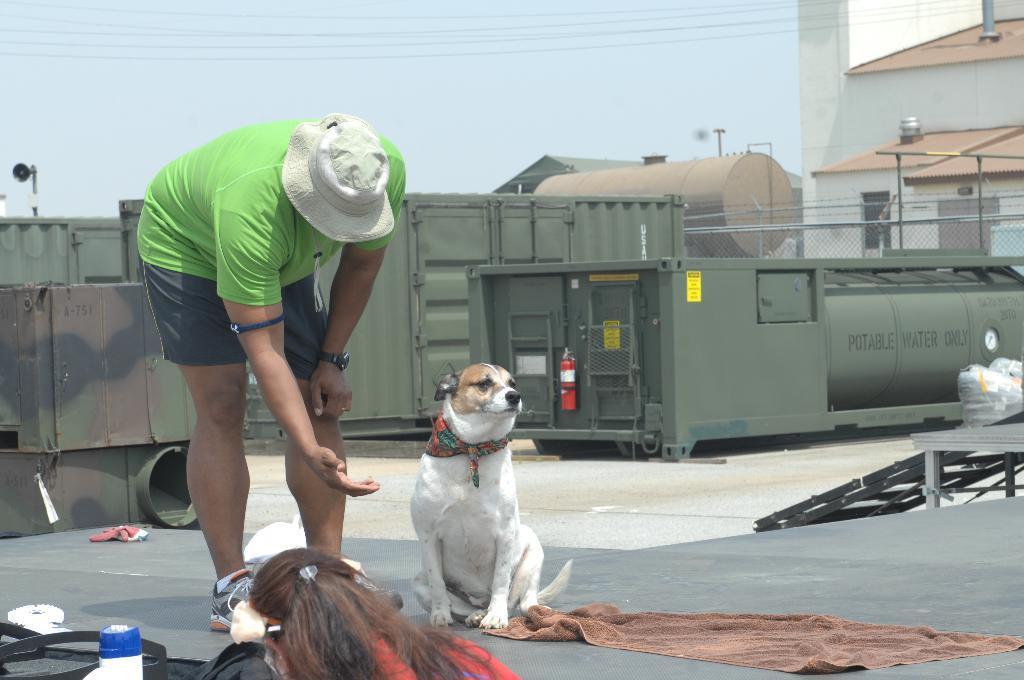In one or two sentences, can you explain what this image depicts? There is a person in light green color t-shirt, bending on a floor near a dog which is sitting on the same floor near a brown color towel which is on the floor. In front of them, there is a person near a white bottle. In the background, there are containers, a tank, buildings which are having roofs, electrical lines and there is blue sky. 